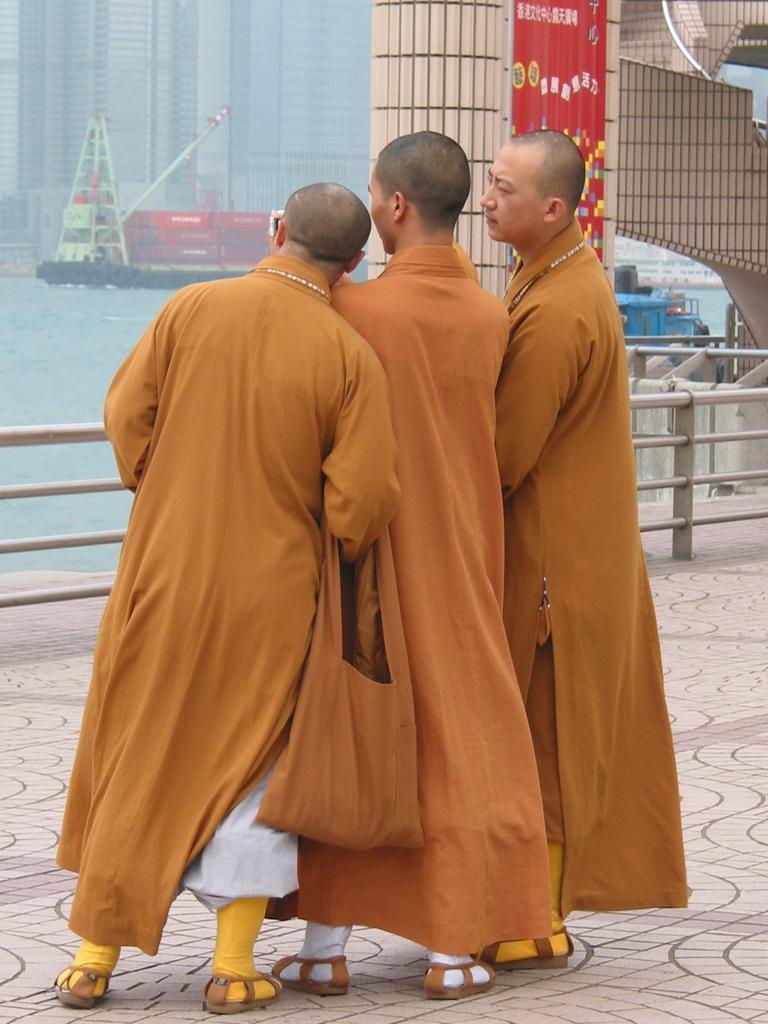In one or two sentences, can you explain what this image depicts? In the center of the image we can see three persons are standing and wearing clothes and a man is carrying a bag and another man is holding a mobile. In the background of the image we can see the barricades, water, boats, buildings, wall, boards. At the bottom of the image we can see the ground. 